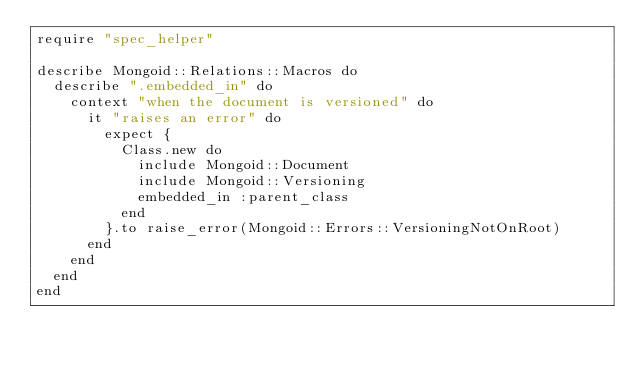<code> <loc_0><loc_0><loc_500><loc_500><_Ruby_>require "spec_helper"

describe Mongoid::Relations::Macros do
  describe ".embedded_in" do
    context "when the document is versioned" do
      it "raises an error" do
        expect {
          Class.new do
            include Mongoid::Document
            include Mongoid::Versioning
            embedded_in :parent_class
          end
        }.to raise_error(Mongoid::Errors::VersioningNotOnRoot)
      end
    end
  end
end
</code> 